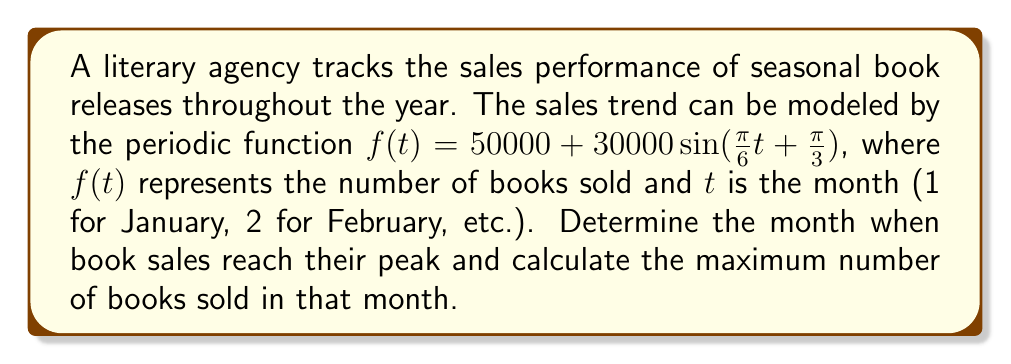Help me with this question. To solve this problem, we'll follow these steps:

1) The general form of a sine function is $a\sin(b(t-c)) + d$, where:
   $a$ is the amplitude
   $b$ is the frequency
   $c$ is the phase shift
   $d$ is the vertical shift

2) In our function $f(t) = 50000 + 30000\sin(\frac{\pi}{6}t + \frac{\pi}{3})$:
   $a = 30000$
   $b = \frac{\pi}{6}$
   $d = 50000$

3) To find the phase shift, we need to rewrite the function in the form $a\sin(b(t-c)) + d$:
   $f(t) = 50000 + 30000\sin(\frac{\pi}{6}(t + 2))$
   So, $c = -2$

4) The sine function reaches its maximum when the argument is $\frac{\pi}{2} + 2\pi n$, where $n$ is an integer.

5) Set up the equation:
   $\frac{\pi}{6}(t + 2) = \frac{\pi}{2}$

6) Solve for $t$:
   $t + 2 = 3$
   $t = 1$

7) This means the sales peak in January (t = 1).

8) To find the maximum number of books sold, plug $t = 1$ into the original function:
   $f(1) = 50000 + 30000\sin(\frac{\pi}{6} + \frac{\pi}{3})$
   $= 50000 + 30000\sin(\frac{\pi}{2})$
   $= 50000 + 30000$
   $= 80000$

Therefore, book sales peak in January with 80,000 books sold.
Answer: January; 80,000 books 